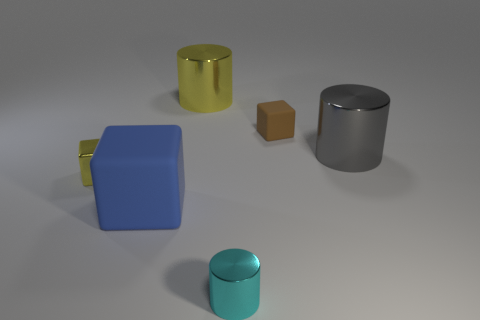How many other things are there of the same material as the big blue cube?
Your answer should be compact. 1. There is a rubber thing that is behind the big blue rubber object; how big is it?
Keep it short and to the point. Small. Is the color of the large cube the same as the tiny metal cylinder?
Give a very brief answer. No. What number of large objects are either brown rubber things or green objects?
Provide a short and direct response. 0. Are there any other things that are the same color as the small matte thing?
Provide a short and direct response. No. Are there any big matte things behind the small brown thing?
Your response must be concise. No. There is a metal cylinder that is behind the big metallic cylinder that is right of the cyan metallic cylinder; what size is it?
Offer a terse response. Large. Is the number of large blue cubes that are in front of the blue rubber object the same as the number of yellow metal objects that are right of the gray metal cylinder?
Provide a short and direct response. Yes. There is a matte thing that is behind the tiny yellow metal block; is there a big blue matte thing that is behind it?
Offer a very short reply. No. What number of big blue matte objects are left of the rubber cube that is on the right side of the large object in front of the small metallic block?
Offer a terse response. 1. 